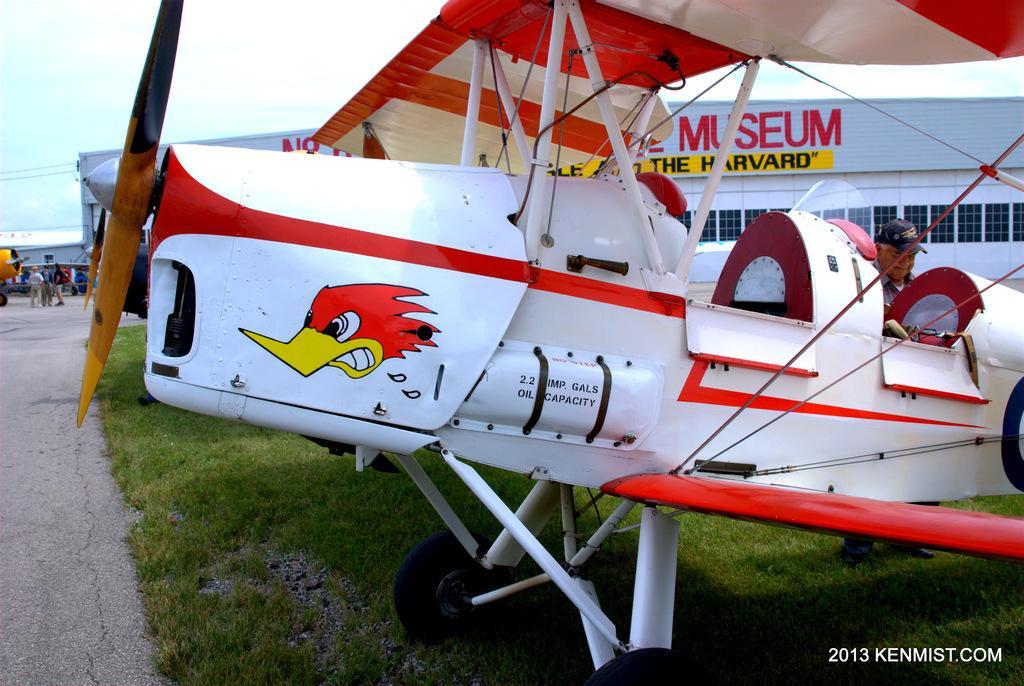Could you give a brief overview of what you see in this image? In this picture we can see an aircraft on the grass, some people on the road, building with windows and some objects and in the background we can see the sky and at the bottom right corner we can see some text. 